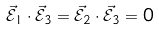Convert formula to latex. <formula><loc_0><loc_0><loc_500><loc_500>\vec { \mathcal { E } } _ { 1 } \cdot \vec { \mathcal { E } } _ { 3 } = \vec { \mathcal { E } } _ { 2 } \cdot \vec { \mathcal { E } } _ { 3 } = 0</formula> 